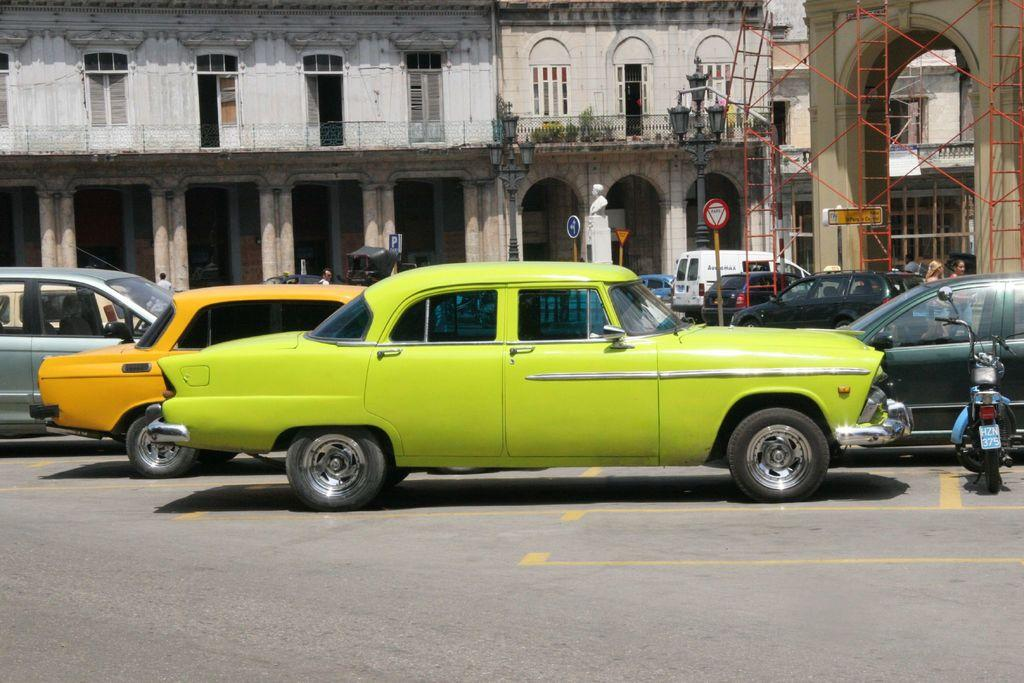<image>
Summarize the visual content of the image. Many cars and a scooter, with the license plate HZN 375, are parked in front of old buildings. 